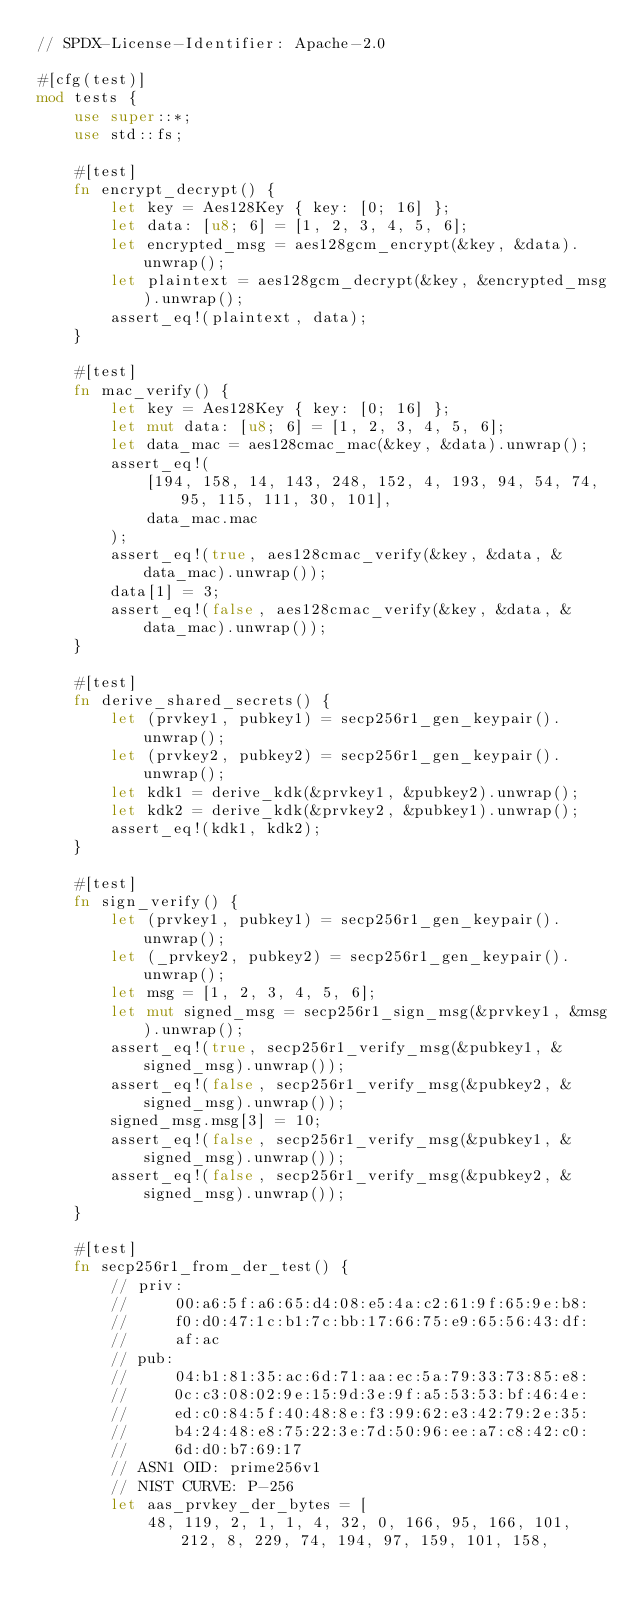<code> <loc_0><loc_0><loc_500><loc_500><_Rust_>// SPDX-License-Identifier: Apache-2.0

#[cfg(test)]
mod tests {
    use super::*;
    use std::fs;

    #[test]
    fn encrypt_decrypt() {
        let key = Aes128Key { key: [0; 16] };
        let data: [u8; 6] = [1, 2, 3, 4, 5, 6];
        let encrypted_msg = aes128gcm_encrypt(&key, &data).unwrap();
        let plaintext = aes128gcm_decrypt(&key, &encrypted_msg).unwrap();
        assert_eq!(plaintext, data);
    }

    #[test]
    fn mac_verify() {
        let key = Aes128Key { key: [0; 16] };
        let mut data: [u8; 6] = [1, 2, 3, 4, 5, 6];
        let data_mac = aes128cmac_mac(&key, &data).unwrap();
        assert_eq!(
            [194, 158, 14, 143, 248, 152, 4, 193, 94, 54, 74, 95, 115, 111, 30, 101],
            data_mac.mac
        );
        assert_eq!(true, aes128cmac_verify(&key, &data, &data_mac).unwrap());
        data[1] = 3;
        assert_eq!(false, aes128cmac_verify(&key, &data, &data_mac).unwrap());
    }

    #[test]
    fn derive_shared_secrets() {
        let (prvkey1, pubkey1) = secp256r1_gen_keypair().unwrap();
        let (prvkey2, pubkey2) = secp256r1_gen_keypair().unwrap();
        let kdk1 = derive_kdk(&prvkey1, &pubkey2).unwrap();
        let kdk2 = derive_kdk(&prvkey2, &pubkey1).unwrap();
        assert_eq!(kdk1, kdk2);
    }

    #[test]
    fn sign_verify() {
        let (prvkey1, pubkey1) = secp256r1_gen_keypair().unwrap();
        let (_prvkey2, pubkey2) = secp256r1_gen_keypair().unwrap();
        let msg = [1, 2, 3, 4, 5, 6];
        let mut signed_msg = secp256r1_sign_msg(&prvkey1, &msg).unwrap();
        assert_eq!(true, secp256r1_verify_msg(&pubkey1, &signed_msg).unwrap());
        assert_eq!(false, secp256r1_verify_msg(&pubkey2, &signed_msg).unwrap());
        signed_msg.msg[3] = 10;
        assert_eq!(false, secp256r1_verify_msg(&pubkey1, &signed_msg).unwrap());
        assert_eq!(false, secp256r1_verify_msg(&pubkey2, &signed_msg).unwrap());
    }

    #[test]
    fn secp256r1_from_der_test() {
        // priv:
        //     00:a6:5f:a6:65:d4:08:e5:4a:c2:61:9f:65:9e:b8:
        //     f0:d0:47:1c:b1:7c:bb:17:66:75:e9:65:56:43:df:
        //     af:ac
        // pub:
        //     04:b1:81:35:ac:6d:71:aa:ec:5a:79:33:73:85:e8:
        //     0c:c3:08:02:9e:15:9d:3e:9f:a5:53:53:bf:46:4e:
        //     ed:c0:84:5f:40:48:8e:f3:99:62:e3:42:79:2e:35:
        //     b4:24:48:e8:75:22:3e:7d:50:96:ee:a7:c8:42:c0:
        //     6d:d0:b7:69:17
        // ASN1 OID: prime256v1
        // NIST CURVE: P-256
        let aas_prvkey_der_bytes = [
            48, 119, 2, 1, 1, 4, 32, 0, 166, 95, 166, 101, 212, 8, 229, 74, 194, 97, 159, 101, 158,</code> 